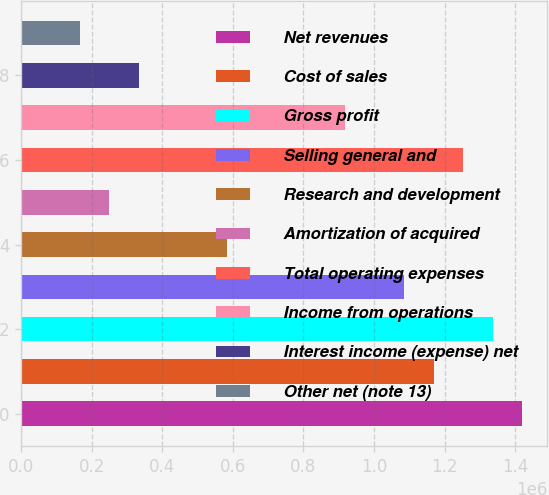<chart> <loc_0><loc_0><loc_500><loc_500><bar_chart><fcel>Net revenues<fcel>Cost of sales<fcel>Gross profit<fcel>Selling general and<fcel>Research and development<fcel>Amortization of acquired<fcel>Total operating expenses<fcel>Income from operations<fcel>Interest income (expense) net<fcel>Other net (note 13)<nl><fcel>1.42017e+06<fcel>1.16956e+06<fcel>1.33663e+06<fcel>1.08602e+06<fcel>584778<fcel>250620<fcel>1.25309e+06<fcel>918937<fcel>334160<fcel>167081<nl></chart> 